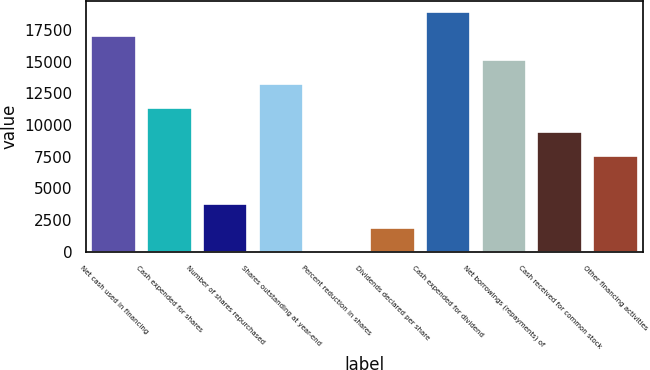<chart> <loc_0><loc_0><loc_500><loc_500><bar_chart><fcel>Net cash used in financing<fcel>Cash expended for shares<fcel>Number of shares repurchased<fcel>Shares outstanding at year-end<fcel>Percent reduction in shares<fcel>Dividends declared per share<fcel>Cash expended for dividend<fcel>Net borrowings (repayments) of<fcel>Cash received for common stock<fcel>Other financing activities<nl><fcel>17003.7<fcel>11335.9<fcel>3778.84<fcel>13225.2<fcel>0.3<fcel>1889.57<fcel>18893<fcel>15114.5<fcel>9446.65<fcel>7557.38<nl></chart> 